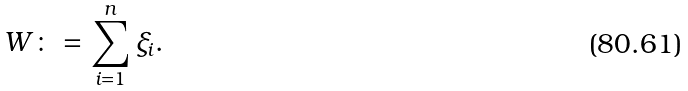<formula> <loc_0><loc_0><loc_500><loc_500>W \colon = \sum _ { i = 1 } ^ { n } \xi _ { i } .</formula> 